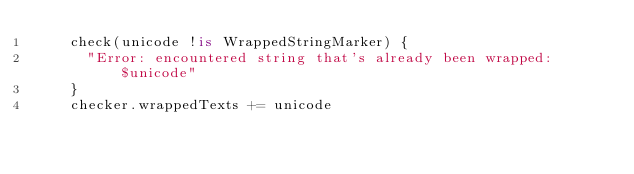<code> <loc_0><loc_0><loc_500><loc_500><_Kotlin_>    check(unicode !is WrappedStringMarker) {
      "Error: encountered string that's already been wrapped: $unicode"
    }
    checker.wrappedTexts += unicode</code> 